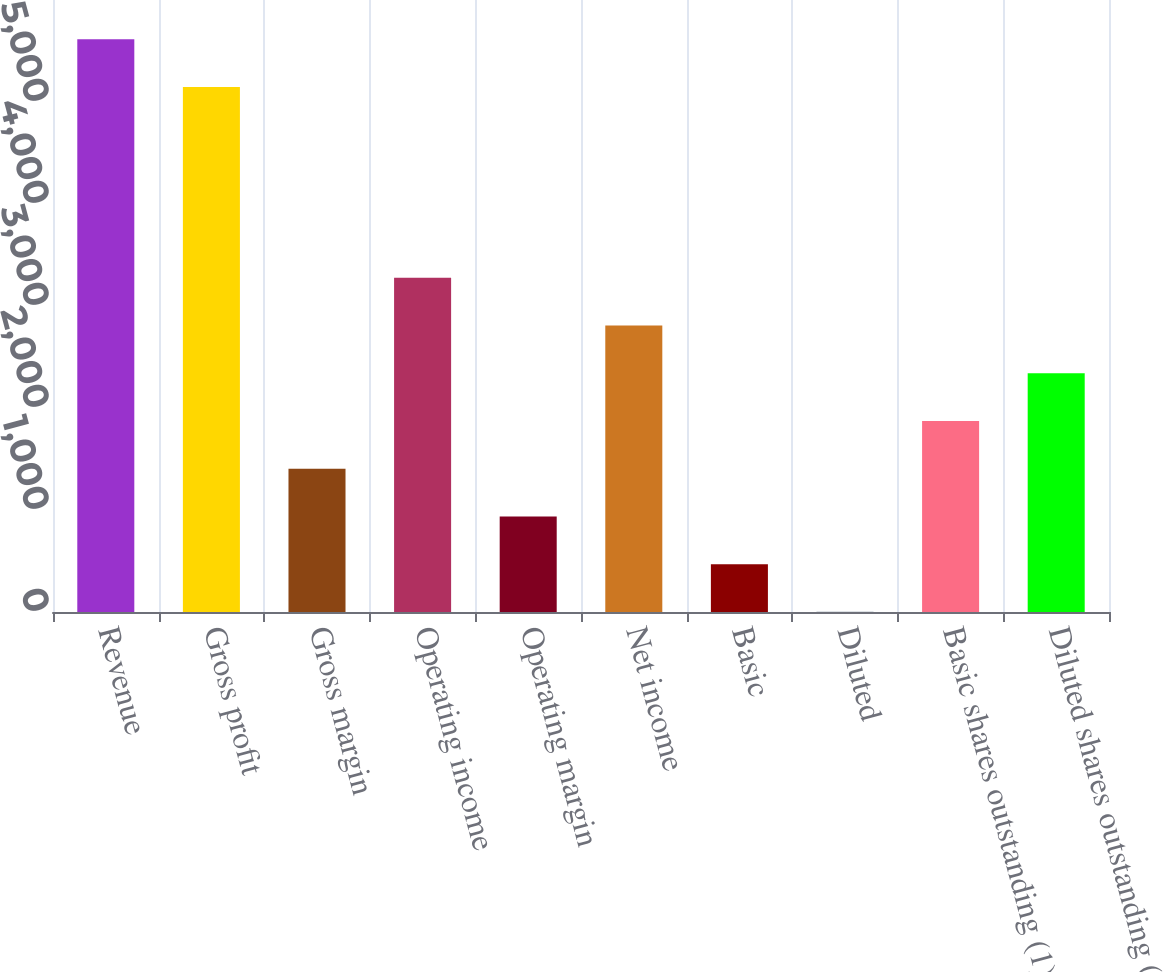Convert chart. <chart><loc_0><loc_0><loc_500><loc_500><bar_chart><fcel>Revenue<fcel>Gross profit<fcel>Gross margin<fcel>Operating income<fcel>Operating margin<fcel>Net income<fcel>Basic<fcel>Diluted<fcel>Basic shares outstanding (1)<fcel>Diluted shares outstanding (1)<nl><fcel>5614.47<fcel>5146.73<fcel>1404.81<fcel>3275.77<fcel>937.07<fcel>2808.03<fcel>469.33<fcel>1.59<fcel>1872.55<fcel>2340.29<nl></chart> 